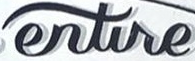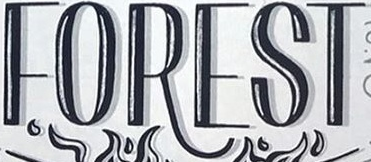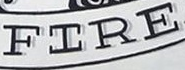Identify the words shown in these images in order, separated by a semicolon. entire; FOREST; FIRE 